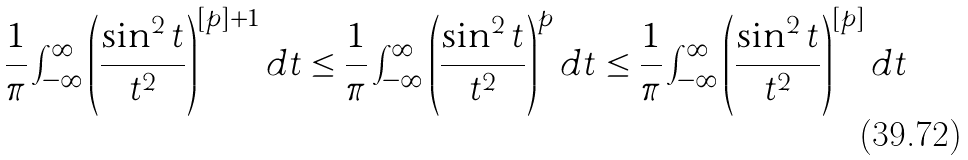<formula> <loc_0><loc_0><loc_500><loc_500>\frac { 1 } { \pi } \int _ { - \infty } ^ { \infty } \left ( \frac { \sin ^ { 2 } t } { t ^ { 2 } } \right ) ^ { [ p ] + 1 } d t \leq \frac { 1 } { \pi } \int _ { - \infty } ^ { \infty } \left ( \frac { \sin ^ { 2 } t } { t ^ { 2 } } \right ) ^ { p } d t \leq \frac { 1 } { \pi } \int _ { - \infty } ^ { \infty } \left ( \frac { \sin ^ { 2 } t } { t ^ { 2 } } \right ) ^ { [ p ] } d t</formula> 